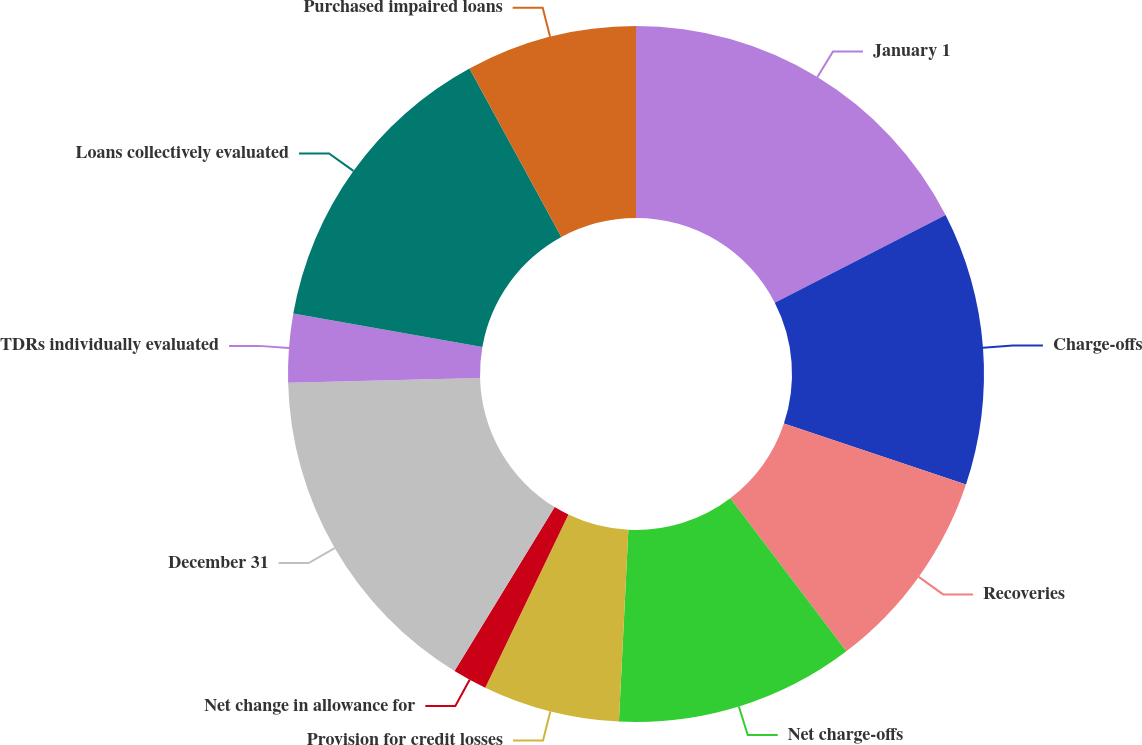<chart> <loc_0><loc_0><loc_500><loc_500><pie_chart><fcel>January 1<fcel>Charge-offs<fcel>Recoveries<fcel>Net charge-offs<fcel>Provision for credit losses<fcel>Net change in allowance for<fcel>December 31<fcel>TDRs individually evaluated<fcel>Loans collectively evaluated<fcel>Purchased impaired loans<nl><fcel>17.45%<fcel>12.69%<fcel>9.52%<fcel>11.11%<fcel>6.35%<fcel>1.6%<fcel>15.86%<fcel>3.18%<fcel>14.28%<fcel>7.94%<nl></chart> 